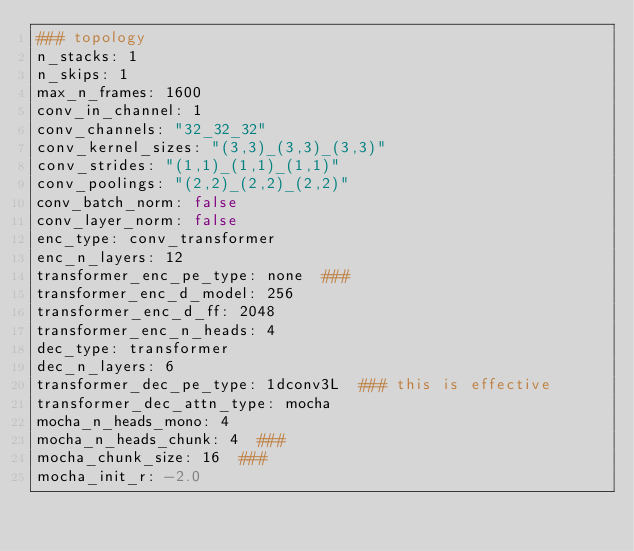<code> <loc_0><loc_0><loc_500><loc_500><_YAML_>### topology
n_stacks: 1
n_skips: 1
max_n_frames: 1600
conv_in_channel: 1
conv_channels: "32_32_32"
conv_kernel_sizes: "(3,3)_(3,3)_(3,3)"
conv_strides: "(1,1)_(1,1)_(1,1)"
conv_poolings: "(2,2)_(2,2)_(2,2)"
conv_batch_norm: false
conv_layer_norm: false
enc_type: conv_transformer
enc_n_layers: 12
transformer_enc_pe_type: none  ###
transformer_enc_d_model: 256
transformer_enc_d_ff: 2048
transformer_enc_n_heads: 4
dec_type: transformer
dec_n_layers: 6
transformer_dec_pe_type: 1dconv3L  ### this is effective
transformer_dec_attn_type: mocha
mocha_n_heads_mono: 4
mocha_n_heads_chunk: 4  ###
mocha_chunk_size: 16  ###
mocha_init_r: -2.0</code> 